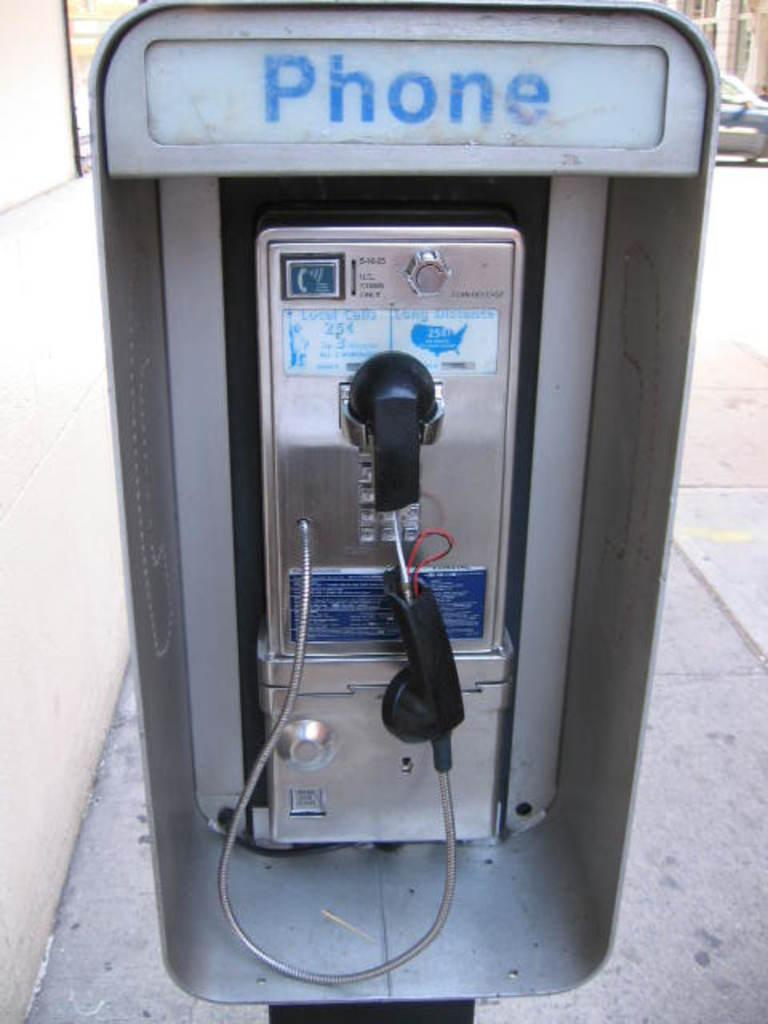<image>
Describe the image concisely. a phone that is outside and a handle on it 